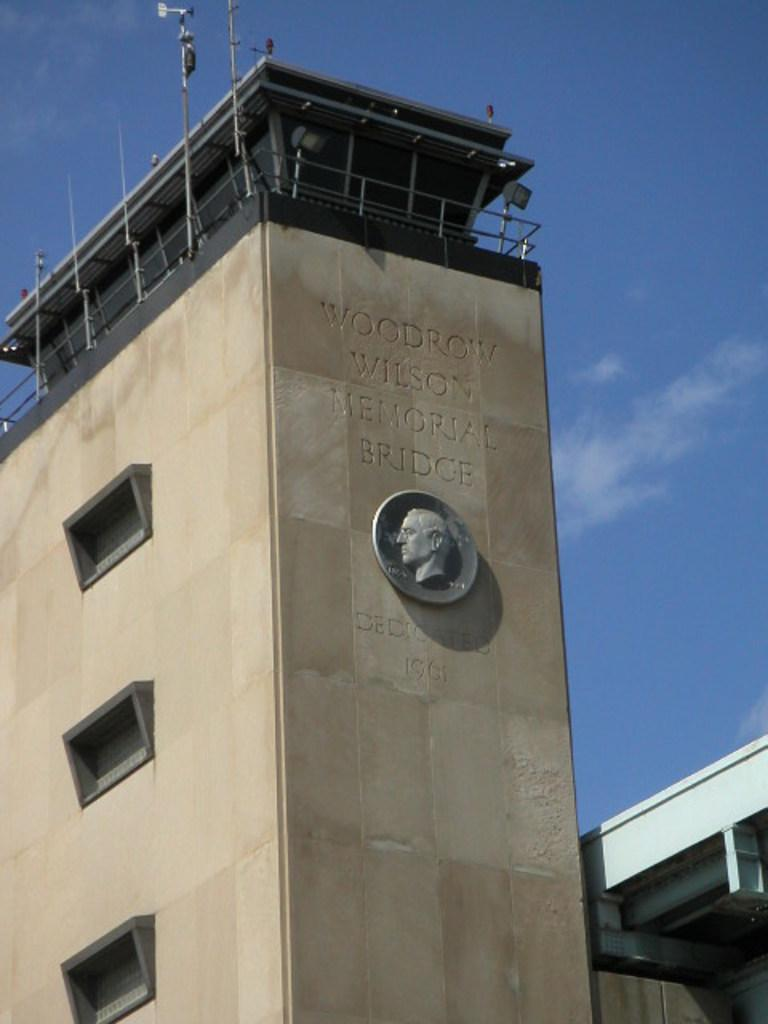What type of structures can be seen in the image? There are buildings in the image. What material can be seen on the buildings in the image? There are metal rods on the buildings in the image. Can you tell me how many firemen are climbing the clam in the image? There is no fireman or clam present in the image; it only features buildings with metal rods. 